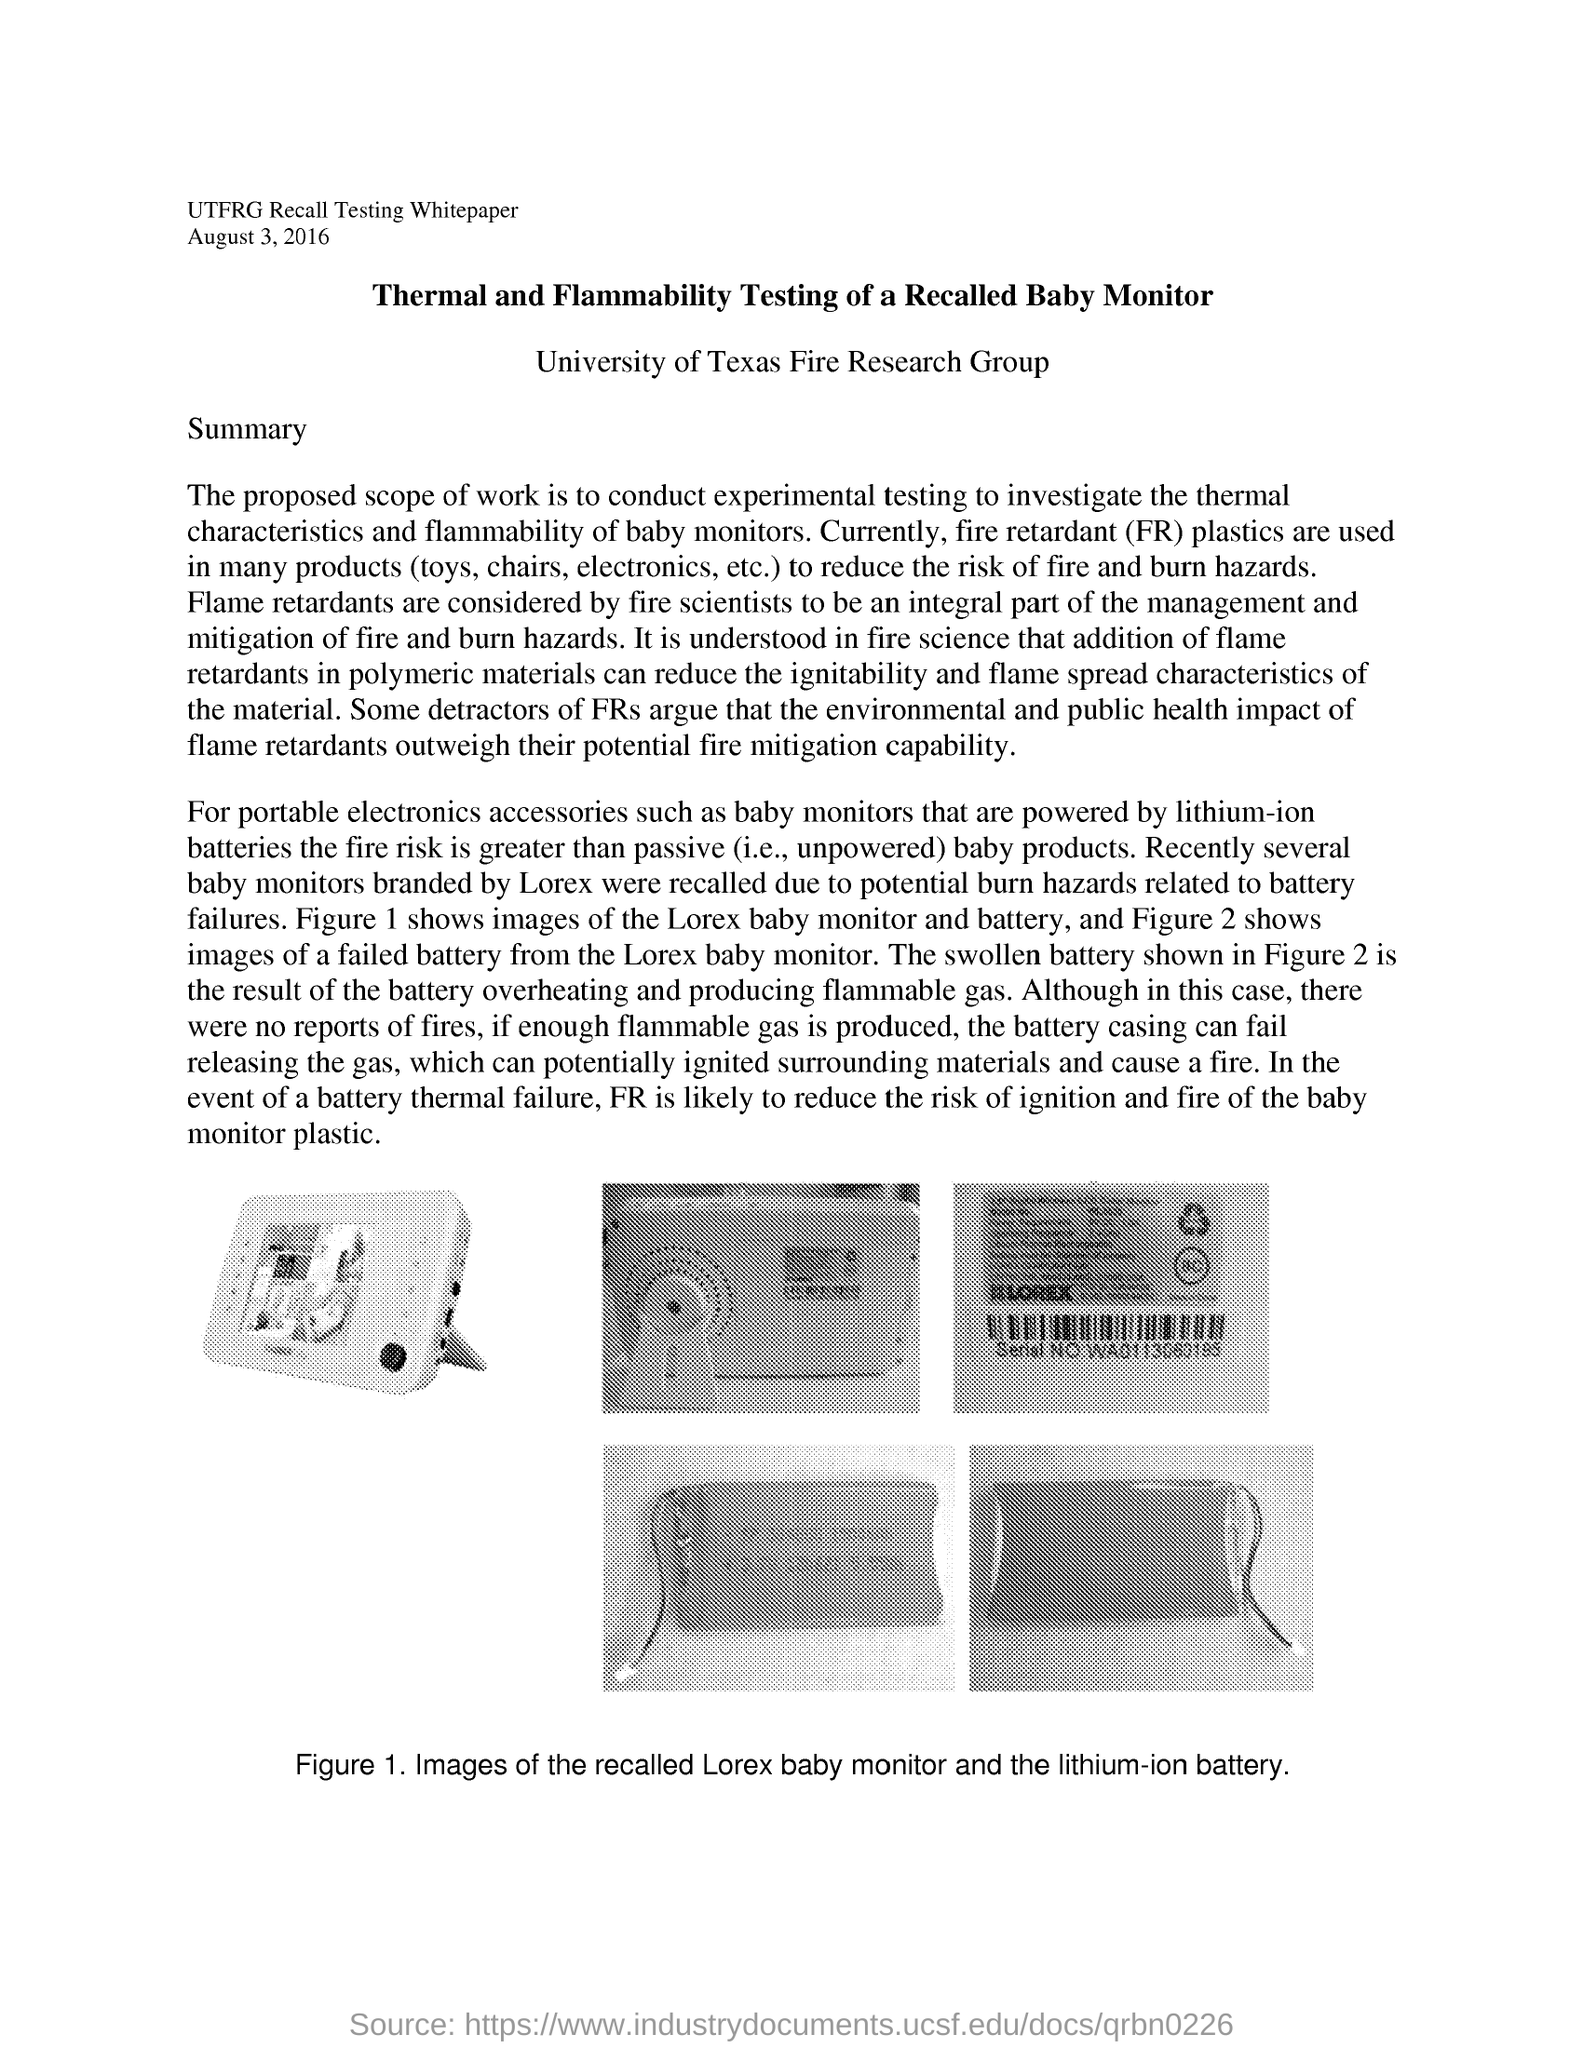List a handful of essential elements in this visual. FR stands for fire retardant. If sufficient flammable gas is produced, the battery casing may fail, causing the gas to be released and potentially leading to ignition of surrounding materials, resulting in a fire. Fire Retardant (FR) plastics play a vital role in reducing the risk of fire and burn hazards in various products such as toys, chairs, electronics, and more. 